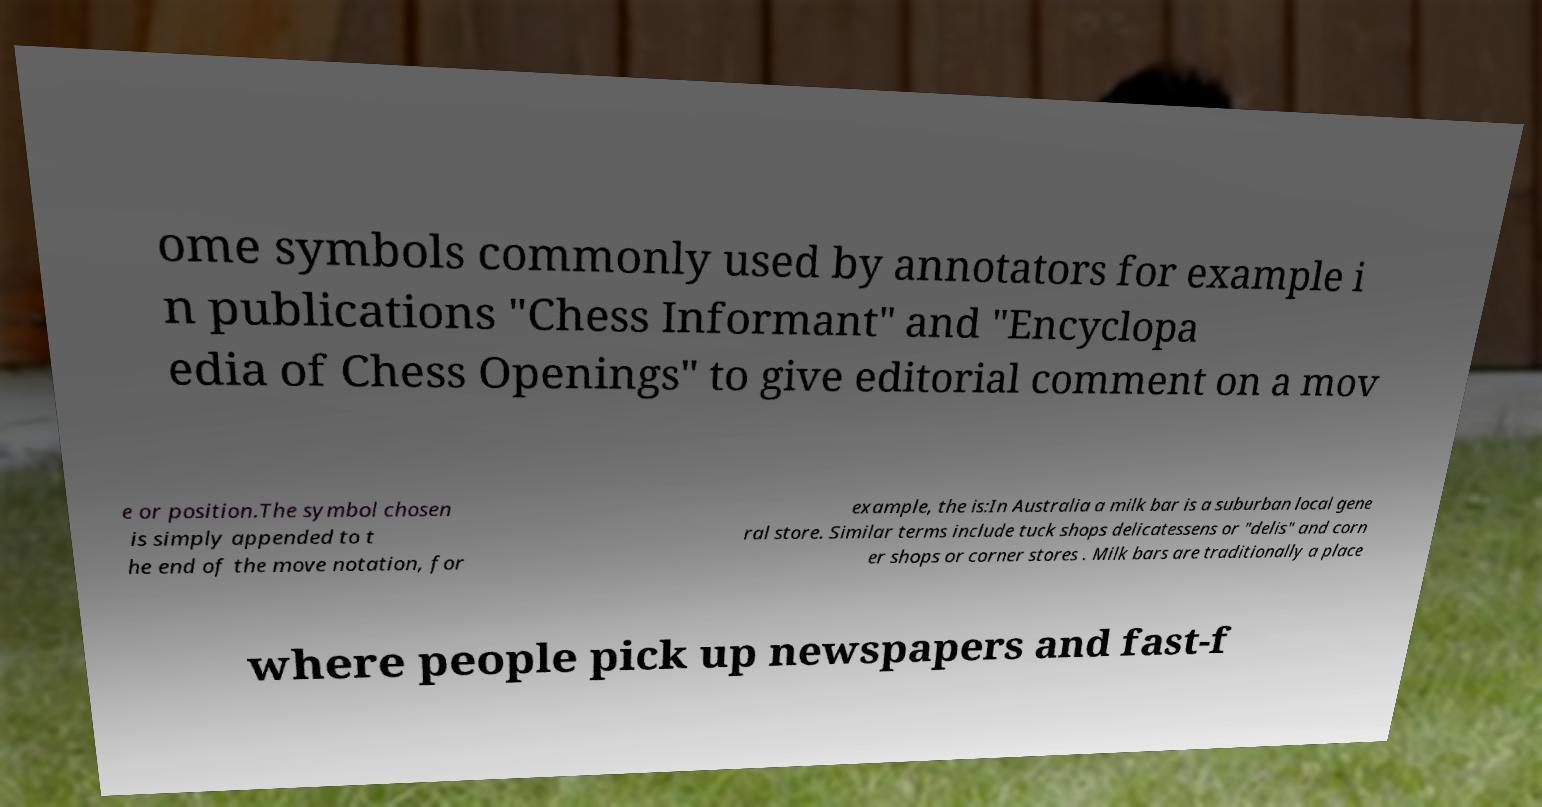Could you extract and type out the text from this image? ome symbols commonly used by annotators for example i n publications "Chess Informant" and "Encyclopa edia of Chess Openings" to give editorial comment on a mov e or position.The symbol chosen is simply appended to t he end of the move notation, for example, the is:In Australia a milk bar is a suburban local gene ral store. Similar terms include tuck shops delicatessens or "delis" and corn er shops or corner stores . Milk bars are traditionally a place where people pick up newspapers and fast-f 